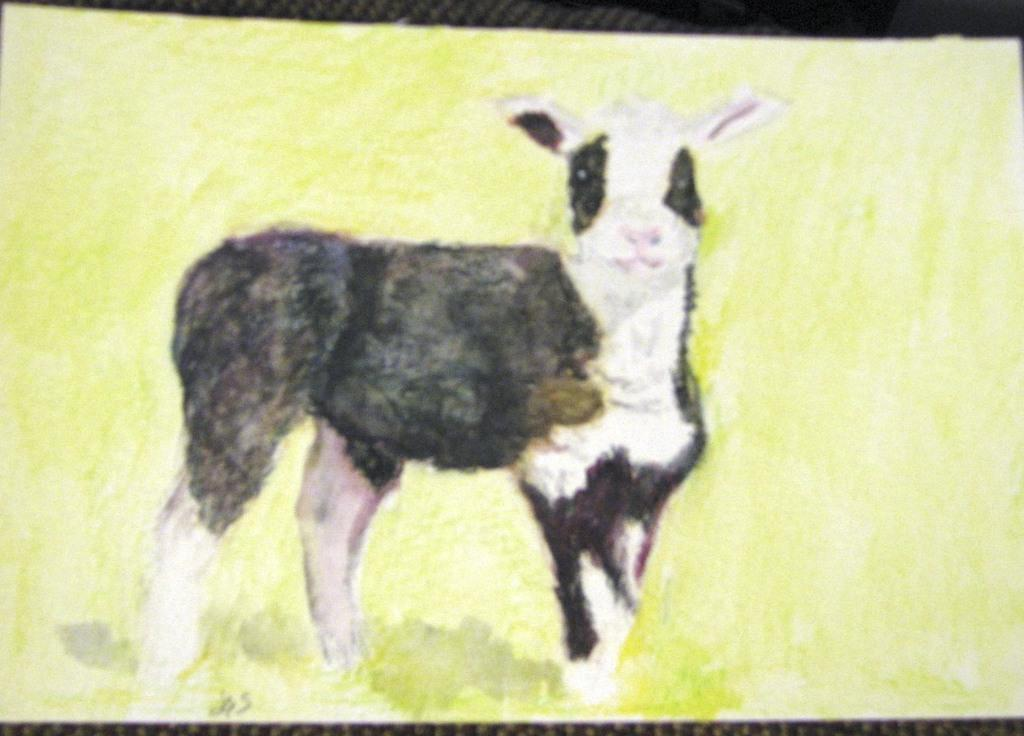What is the main subject of the image? There is a painting in the image. What is depicted in the painting? The painting is of an animal. What material is the painting on? The painting is on paper. What type of library can be seen in the background of the image? There is no library present in the image; it features a painting on paper. What type of toad is depicted in the painting? There is no toad depicted in the painting; it is of an animal, but the specific type is not mentioned in the facts. 